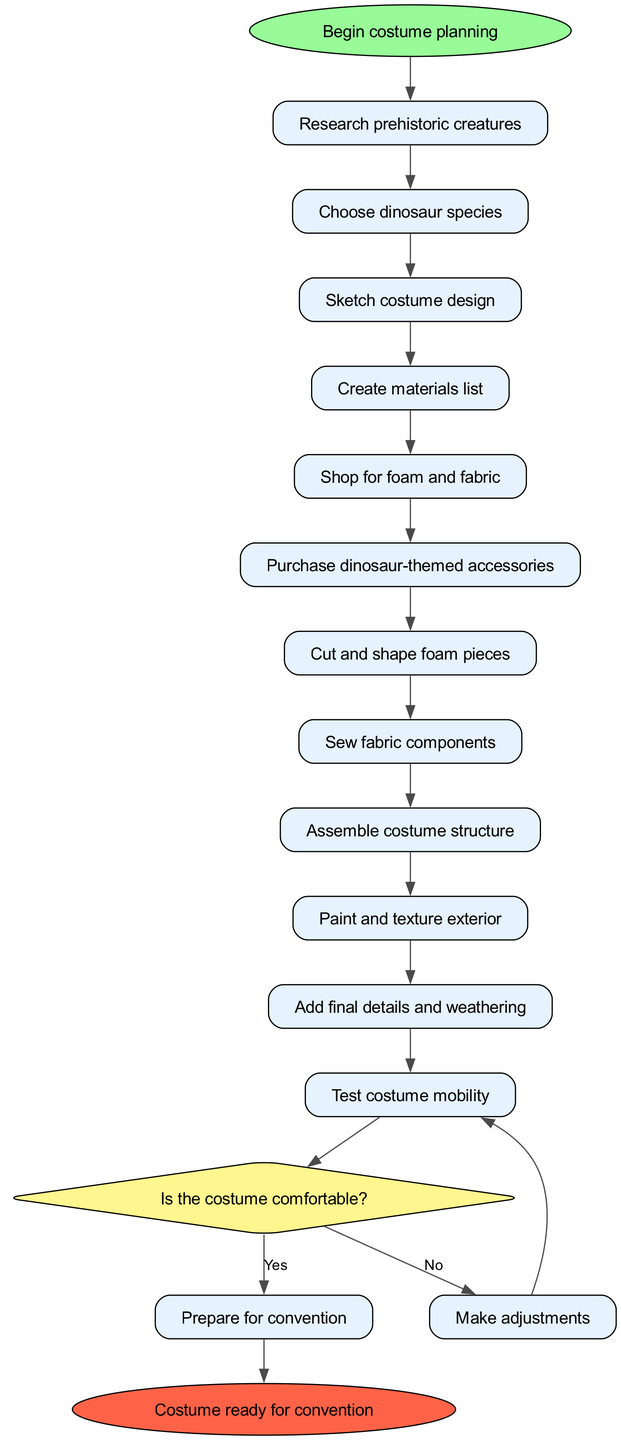What is the starting point of the activity diagram? The starting point of the diagram is labeled as "Begin costume planning," which indicates where the sequence of activities begins.
Answer: Begin costume planning How many activities are listed in the diagram? Counting through the activities mentioned, there are 12 activities that detail various steps in creating the costume, from research to testing mobility.
Answer: 12 What is the final step before the costume is ready for the convention? The last activity before reaching the end is labeled "Test costume mobility," which assesses whether the costume is comfortable and functional for the wearer.
Answer: Test costume mobility What happens if the decision regarding costume comfort is "No"? If the response to the comfort question is "No," the flow returns to "Make adjustments," indicating that alterations will be made to improve comfort before proceeding to prepare for the convention.
Answer: Make adjustments What does the diagram lead to after the decision is "Yes"? If the decision to the comfort question is "Yes," the flow leads directly to "Prepare for convention," indicating readiness for the event.
Answer: Prepare for convention How does the decision node relate to the activities in the diagram? The decision node connects to the last activity, allowing for two possible outcomes based on the comfort level of the costume after completing the assembly and detailing steps, influencing whether adjustments are made or preparation for the convention occurs.
Answer: It connects to the last activity 